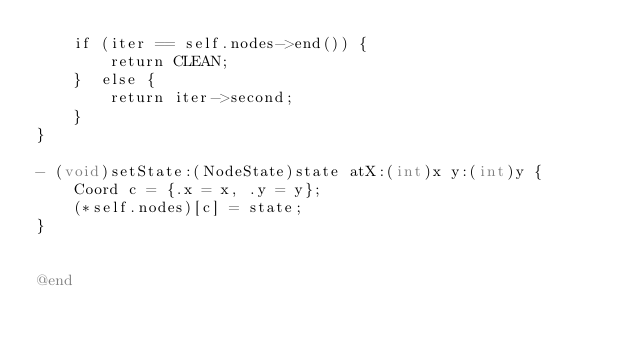Convert code to text. <code><loc_0><loc_0><loc_500><loc_500><_ObjectiveC_>    if (iter == self.nodes->end()) {
        return CLEAN;
    }  else {
        return iter->second;
    }
}

- (void)setState:(NodeState)state atX:(int)x y:(int)y {
    Coord c = {.x = x, .y = y};
    (*self.nodes)[c] = state;
}


@end
</code> 